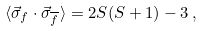Convert formula to latex. <formula><loc_0><loc_0><loc_500><loc_500>\langle \vec { \sigma } _ { f } \cdot \vec { \sigma } _ { \overline { f } } \rangle = 2 S ( S + 1 ) - 3 \, ,</formula> 